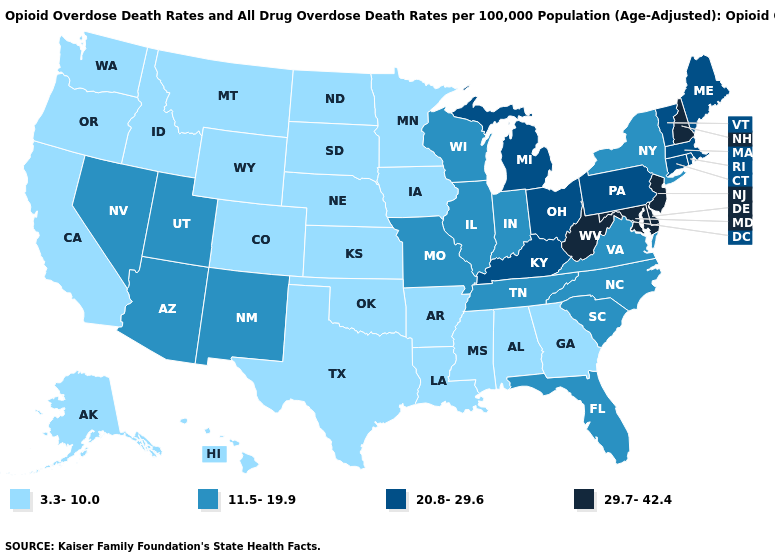Name the states that have a value in the range 29.7-42.4?
Give a very brief answer. Delaware, Maryland, New Hampshire, New Jersey, West Virginia. Name the states that have a value in the range 11.5-19.9?
Answer briefly. Arizona, Florida, Illinois, Indiana, Missouri, Nevada, New Mexico, New York, North Carolina, South Carolina, Tennessee, Utah, Virginia, Wisconsin. Does Pennsylvania have a higher value than West Virginia?
Keep it brief. No. Does Washington have the lowest value in the West?
Write a very short answer. Yes. Does Kansas have a higher value than Minnesota?
Answer briefly. No. What is the highest value in the USA?
Concise answer only. 29.7-42.4. Which states hav the highest value in the Northeast?
Answer briefly. New Hampshire, New Jersey. What is the lowest value in the USA?
Quick response, please. 3.3-10.0. Among the states that border Georgia , which have the highest value?
Be succinct. Florida, North Carolina, South Carolina, Tennessee. Does Colorado have the highest value in the USA?
Give a very brief answer. No. Among the states that border Arizona , which have the highest value?
Quick response, please. Nevada, New Mexico, Utah. Does Nevada have a higher value than Wisconsin?
Answer briefly. No. Among the states that border New Jersey , does Delaware have the highest value?
Quick response, please. Yes. What is the highest value in the USA?
Concise answer only. 29.7-42.4. Name the states that have a value in the range 29.7-42.4?
Answer briefly. Delaware, Maryland, New Hampshire, New Jersey, West Virginia. 